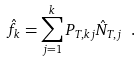<formula> <loc_0><loc_0><loc_500><loc_500>\hat { f } _ { k } = \sum _ { j = 1 } ^ { k } P _ { T , k j } \hat { N } _ { T , j } \ .</formula> 